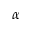<formula> <loc_0><loc_0><loc_500><loc_500>\alpha</formula> 